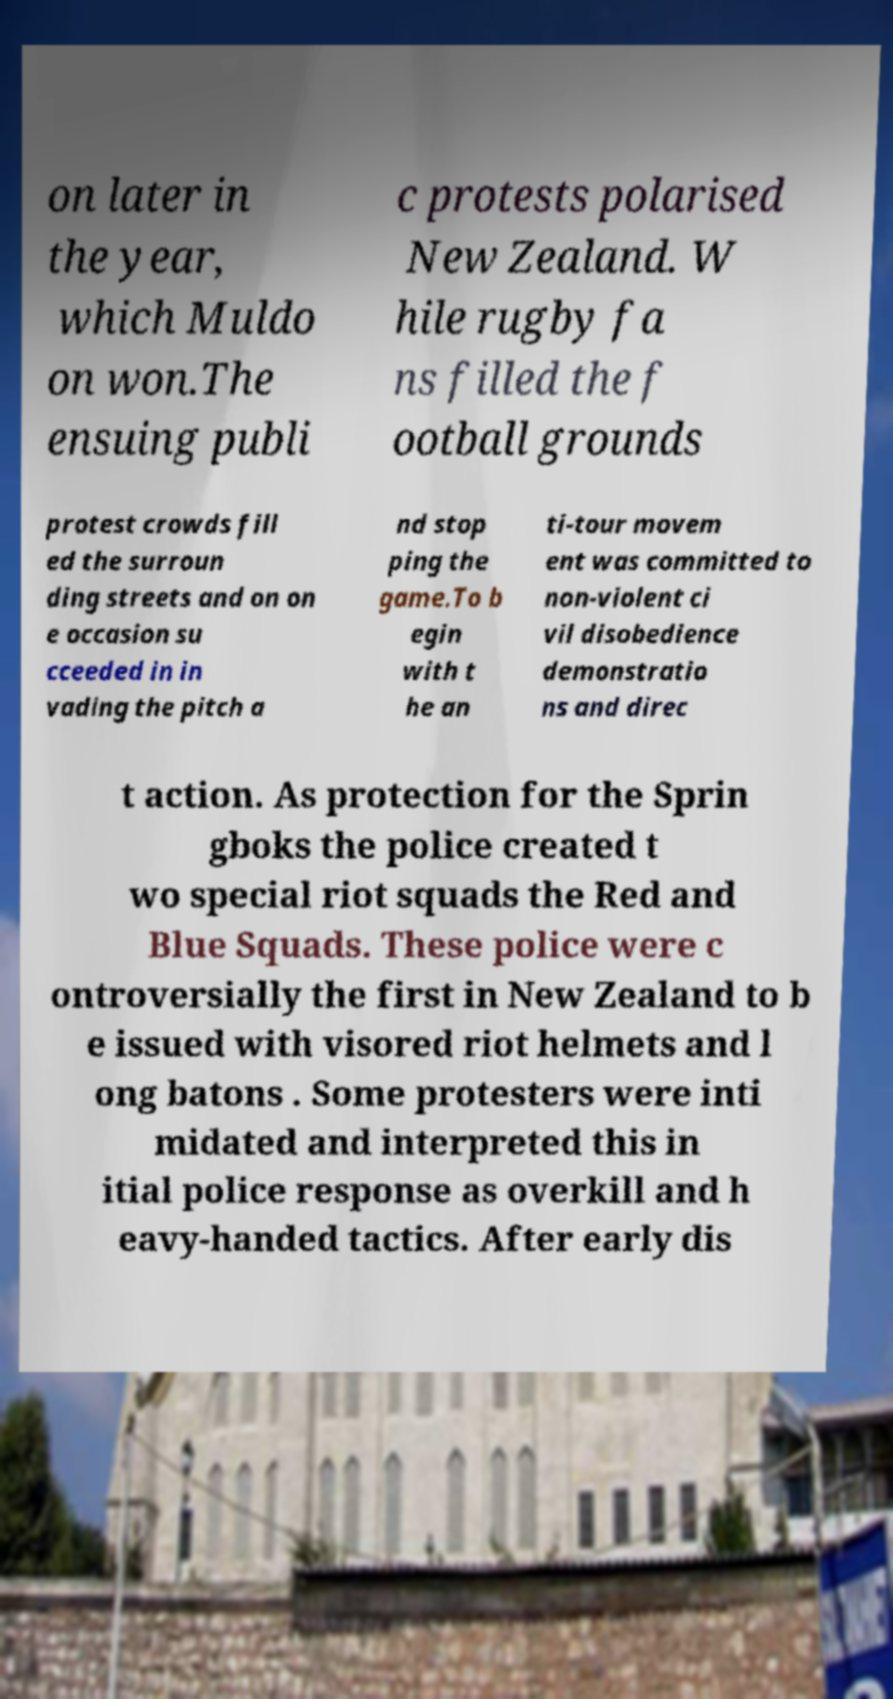Could you extract and type out the text from this image? on later in the year, which Muldo on won.The ensuing publi c protests polarised New Zealand. W hile rugby fa ns filled the f ootball grounds protest crowds fill ed the surroun ding streets and on on e occasion su cceeded in in vading the pitch a nd stop ping the game.To b egin with t he an ti-tour movem ent was committed to non-violent ci vil disobedience demonstratio ns and direc t action. As protection for the Sprin gboks the police created t wo special riot squads the Red and Blue Squads. These police were c ontroversially the first in New Zealand to b e issued with visored riot helmets and l ong batons . Some protesters were inti midated and interpreted this in itial police response as overkill and h eavy-handed tactics. After early dis 